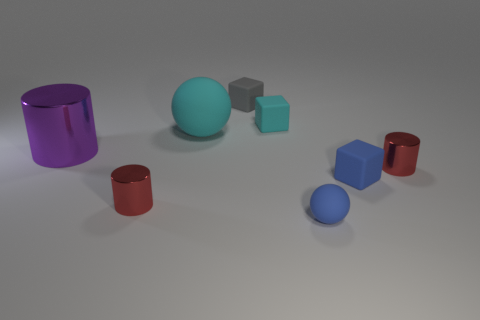Add 1 tiny brown cylinders. How many objects exist? 9 Subtract all spheres. How many objects are left? 6 Subtract all gray rubber things. Subtract all small blue matte things. How many objects are left? 5 Add 1 cyan matte balls. How many cyan matte balls are left? 2 Add 3 small gray objects. How many small gray objects exist? 4 Subtract 1 red cylinders. How many objects are left? 7 